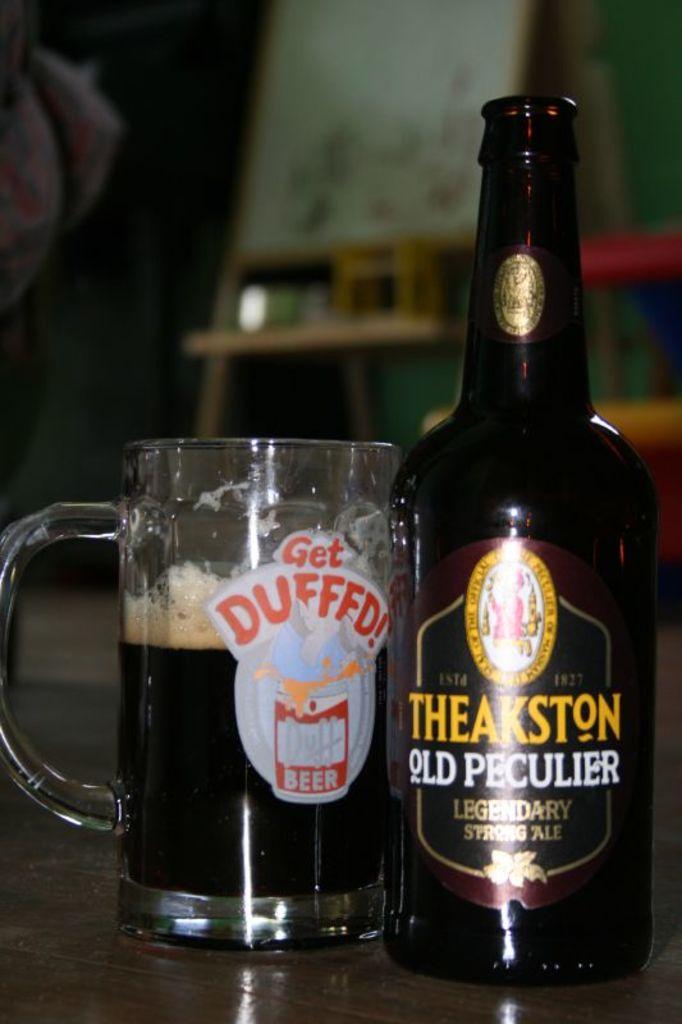What kind of beer is this?
Ensure brevity in your answer.  Theakston old peculier. What does the glass tell you to get?
Your answer should be very brief. Duffed. 